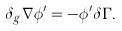<formula> <loc_0><loc_0><loc_500><loc_500>\delta _ { g } \nabla \phi ^ { \prime } = - \phi ^ { \prime } \delta \Gamma .</formula> 